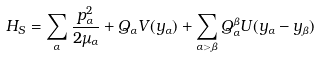<formula> <loc_0><loc_0><loc_500><loc_500>H _ { S } = \sum _ { \alpha } \frac { p _ { \alpha } ^ { 2 } } { 2 \mu _ { \alpha } } + Q _ { \alpha } V ( y _ { \alpha } ) + \sum _ { \alpha > \beta } Q _ { \alpha } ^ { \beta } U ( y _ { \alpha } - y _ { \beta } )</formula> 